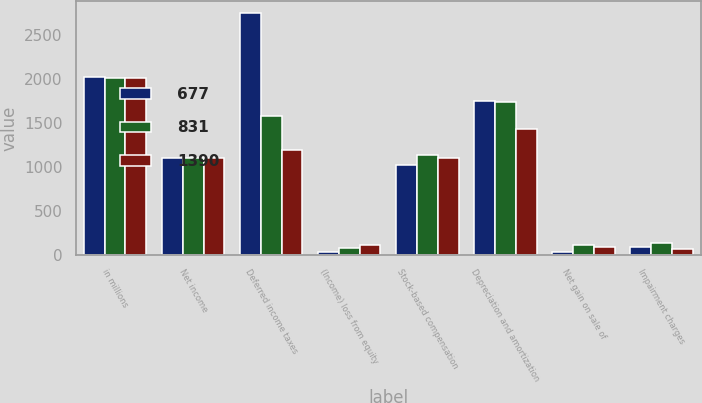<chart> <loc_0><loc_0><loc_500><loc_500><stacked_bar_chart><ecel><fcel>in millions<fcel>Net income<fcel>Deferred income taxes<fcel>(Income) loss from equity<fcel>Stock-based compensation<fcel>Depreciation and amortization<fcel>Net gain on sale of<fcel>Impairment charges<nl><fcel>677<fcel>2017<fcel>1104<fcel>2747<fcel>34<fcel>1026<fcel>1753<fcel>35<fcel>91<nl><fcel>831<fcel>2016<fcel>1104<fcel>1579<fcel>79<fcel>1136<fcel>1736<fcel>112<fcel>130<nl><fcel>1390<fcel>2015<fcel>1104<fcel>1189<fcel>114<fcel>1104<fcel>1433<fcel>84<fcel>69<nl></chart> 